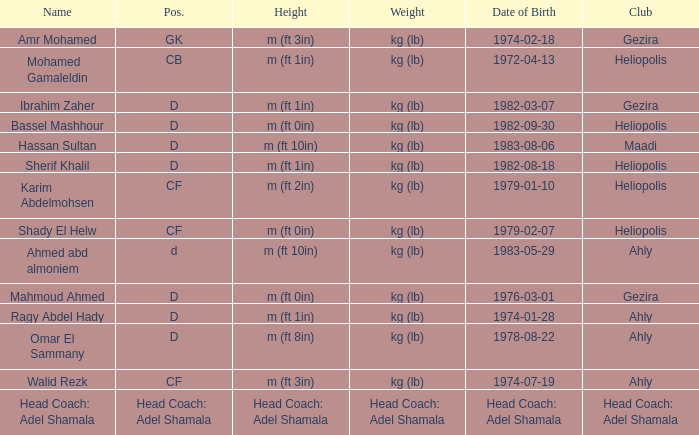What is Name, when Weight is "kg (lb)", when Club is "Gezira", and when Date of Birth is "1974-02-18"? Amr Mohamed. Help me parse the entirety of this table. {'header': ['Name', 'Pos.', 'Height', 'Weight', 'Date of Birth', 'Club'], 'rows': [['Amr Mohamed', 'GK', 'm (ft 3in)', 'kg (lb)', '1974-02-18', 'Gezira'], ['Mohamed Gamaleldin', 'CB', 'm (ft 1in)', 'kg (lb)', '1972-04-13', 'Heliopolis'], ['Ibrahim Zaher', 'D', 'm (ft 1in)', 'kg (lb)', '1982-03-07', 'Gezira'], ['Bassel Mashhour', 'D', 'm (ft 0in)', 'kg (lb)', '1982-09-30', 'Heliopolis'], ['Hassan Sultan', 'D', 'm (ft 10in)', 'kg (lb)', '1983-08-06', 'Maadi'], ['Sherif Khalil', 'D', 'm (ft 1in)', 'kg (lb)', '1982-08-18', 'Heliopolis'], ['Karim Abdelmohsen', 'CF', 'm (ft 2in)', 'kg (lb)', '1979-01-10', 'Heliopolis'], ['Shady El Helw', 'CF', 'm (ft 0in)', 'kg (lb)', '1979-02-07', 'Heliopolis'], ['Ahmed abd almoniem', 'd', 'm (ft 10in)', 'kg (lb)', '1983-05-29', 'Ahly'], ['Mahmoud Ahmed', 'D', 'm (ft 0in)', 'kg (lb)', '1976-03-01', 'Gezira'], ['Ragy Abdel Hady', 'D', 'm (ft 1in)', 'kg (lb)', '1974-01-28', 'Ahly'], ['Omar El Sammany', 'D', 'm (ft 8in)', 'kg (lb)', '1978-08-22', 'Ahly'], ['Walid Rezk', 'CF', 'm (ft 3in)', 'kg (lb)', '1974-07-19', 'Ahly'], ['Head Coach: Adel Shamala', 'Head Coach: Adel Shamala', 'Head Coach: Adel Shamala', 'Head Coach: Adel Shamala', 'Head Coach: Adel Shamala', 'Head Coach: Adel Shamala']]} 